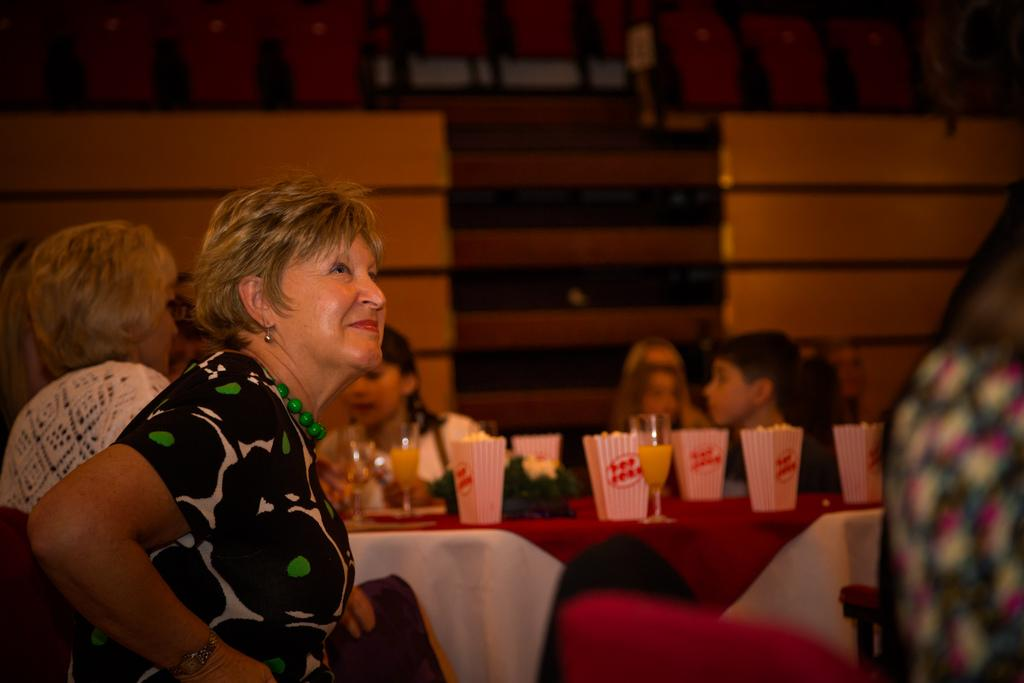What are the people in the image doing? The people in the image are sitting on chairs. How are the chairs arranged in the image? The chairs are arranged around a table. What can be seen on the table in the image? There are glasses and cups on the table. What type of nail is being used to measure the length of the trail in the image? There is no nail, measurement, or trail present in the image. 